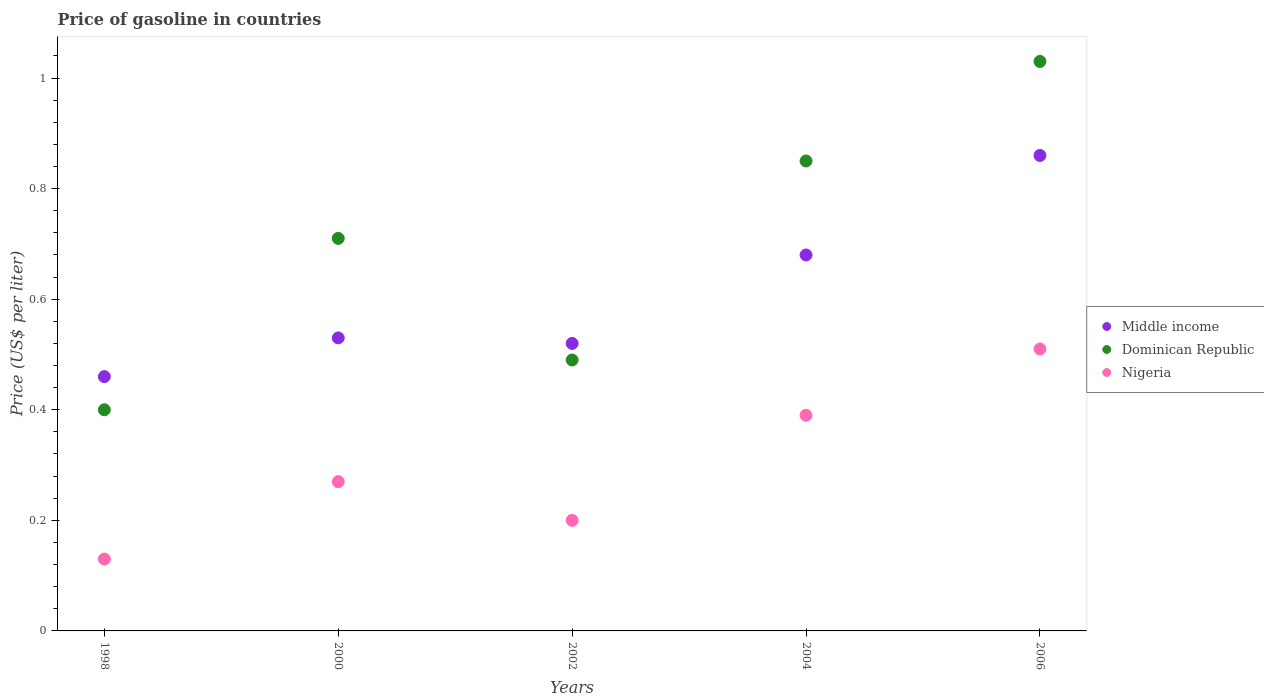Is the number of dotlines equal to the number of legend labels?
Your answer should be compact. Yes. What is the price of gasoline in Middle income in 2004?
Give a very brief answer. 0.68. Across all years, what is the maximum price of gasoline in Middle income?
Offer a very short reply. 0.86. Across all years, what is the minimum price of gasoline in Nigeria?
Provide a succinct answer. 0.13. What is the total price of gasoline in Dominican Republic in the graph?
Give a very brief answer. 3.48. What is the difference between the price of gasoline in Dominican Republic in 2004 and that in 2006?
Offer a very short reply. -0.18. What is the difference between the price of gasoline in Middle income in 2006 and the price of gasoline in Dominican Republic in 2000?
Offer a terse response. 0.15. What is the average price of gasoline in Nigeria per year?
Ensure brevity in your answer.  0.3. In the year 2006, what is the difference between the price of gasoline in Dominican Republic and price of gasoline in Middle income?
Give a very brief answer. 0.17. What is the ratio of the price of gasoline in Dominican Republic in 2002 to that in 2004?
Give a very brief answer. 0.58. Is the price of gasoline in Nigeria in 2000 less than that in 2006?
Offer a terse response. Yes. What is the difference between the highest and the second highest price of gasoline in Middle income?
Offer a very short reply. 0.18. What is the difference between the highest and the lowest price of gasoline in Dominican Republic?
Offer a terse response. 0.63. In how many years, is the price of gasoline in Nigeria greater than the average price of gasoline in Nigeria taken over all years?
Ensure brevity in your answer.  2. Is the sum of the price of gasoline in Dominican Republic in 2000 and 2002 greater than the maximum price of gasoline in Middle income across all years?
Ensure brevity in your answer.  Yes. Is the price of gasoline in Dominican Republic strictly greater than the price of gasoline in Nigeria over the years?
Give a very brief answer. Yes. What is the difference between two consecutive major ticks on the Y-axis?
Offer a very short reply. 0.2. Does the graph contain any zero values?
Provide a succinct answer. No. Does the graph contain grids?
Offer a terse response. No. Where does the legend appear in the graph?
Your answer should be compact. Center right. How many legend labels are there?
Provide a short and direct response. 3. What is the title of the graph?
Give a very brief answer. Price of gasoline in countries. What is the label or title of the X-axis?
Provide a succinct answer. Years. What is the label or title of the Y-axis?
Offer a terse response. Price (US$ per liter). What is the Price (US$ per liter) of Middle income in 1998?
Ensure brevity in your answer.  0.46. What is the Price (US$ per liter) in Nigeria in 1998?
Keep it short and to the point. 0.13. What is the Price (US$ per liter) in Middle income in 2000?
Your response must be concise. 0.53. What is the Price (US$ per liter) in Dominican Republic in 2000?
Provide a short and direct response. 0.71. What is the Price (US$ per liter) in Nigeria in 2000?
Your answer should be very brief. 0.27. What is the Price (US$ per liter) of Middle income in 2002?
Your answer should be very brief. 0.52. What is the Price (US$ per liter) of Dominican Republic in 2002?
Offer a very short reply. 0.49. What is the Price (US$ per liter) of Nigeria in 2002?
Offer a terse response. 0.2. What is the Price (US$ per liter) in Middle income in 2004?
Your answer should be very brief. 0.68. What is the Price (US$ per liter) in Nigeria in 2004?
Your answer should be compact. 0.39. What is the Price (US$ per liter) of Middle income in 2006?
Your answer should be very brief. 0.86. What is the Price (US$ per liter) in Dominican Republic in 2006?
Your answer should be very brief. 1.03. What is the Price (US$ per liter) in Nigeria in 2006?
Your response must be concise. 0.51. Across all years, what is the maximum Price (US$ per liter) of Middle income?
Offer a very short reply. 0.86. Across all years, what is the maximum Price (US$ per liter) in Dominican Republic?
Offer a terse response. 1.03. Across all years, what is the maximum Price (US$ per liter) in Nigeria?
Make the answer very short. 0.51. Across all years, what is the minimum Price (US$ per liter) of Middle income?
Your answer should be compact. 0.46. Across all years, what is the minimum Price (US$ per liter) in Dominican Republic?
Keep it short and to the point. 0.4. Across all years, what is the minimum Price (US$ per liter) in Nigeria?
Ensure brevity in your answer.  0.13. What is the total Price (US$ per liter) in Middle income in the graph?
Ensure brevity in your answer.  3.05. What is the total Price (US$ per liter) of Dominican Republic in the graph?
Your answer should be compact. 3.48. What is the difference between the Price (US$ per liter) of Middle income in 1998 and that in 2000?
Give a very brief answer. -0.07. What is the difference between the Price (US$ per liter) of Dominican Republic in 1998 and that in 2000?
Provide a short and direct response. -0.31. What is the difference between the Price (US$ per liter) of Nigeria in 1998 and that in 2000?
Give a very brief answer. -0.14. What is the difference between the Price (US$ per liter) in Middle income in 1998 and that in 2002?
Ensure brevity in your answer.  -0.06. What is the difference between the Price (US$ per liter) in Dominican Republic in 1998 and that in 2002?
Keep it short and to the point. -0.09. What is the difference between the Price (US$ per liter) of Nigeria in 1998 and that in 2002?
Ensure brevity in your answer.  -0.07. What is the difference between the Price (US$ per liter) of Middle income in 1998 and that in 2004?
Offer a terse response. -0.22. What is the difference between the Price (US$ per liter) of Dominican Republic in 1998 and that in 2004?
Provide a short and direct response. -0.45. What is the difference between the Price (US$ per liter) of Nigeria in 1998 and that in 2004?
Offer a very short reply. -0.26. What is the difference between the Price (US$ per liter) of Dominican Republic in 1998 and that in 2006?
Your answer should be very brief. -0.63. What is the difference between the Price (US$ per liter) in Nigeria in 1998 and that in 2006?
Your answer should be compact. -0.38. What is the difference between the Price (US$ per liter) in Dominican Republic in 2000 and that in 2002?
Provide a succinct answer. 0.22. What is the difference between the Price (US$ per liter) of Nigeria in 2000 and that in 2002?
Offer a very short reply. 0.07. What is the difference between the Price (US$ per liter) in Dominican Republic in 2000 and that in 2004?
Your answer should be compact. -0.14. What is the difference between the Price (US$ per liter) of Nigeria in 2000 and that in 2004?
Offer a terse response. -0.12. What is the difference between the Price (US$ per liter) of Middle income in 2000 and that in 2006?
Make the answer very short. -0.33. What is the difference between the Price (US$ per liter) of Dominican Republic in 2000 and that in 2006?
Offer a terse response. -0.32. What is the difference between the Price (US$ per liter) in Nigeria in 2000 and that in 2006?
Keep it short and to the point. -0.24. What is the difference between the Price (US$ per liter) in Middle income in 2002 and that in 2004?
Your response must be concise. -0.16. What is the difference between the Price (US$ per liter) of Dominican Republic in 2002 and that in 2004?
Keep it short and to the point. -0.36. What is the difference between the Price (US$ per liter) in Nigeria in 2002 and that in 2004?
Make the answer very short. -0.19. What is the difference between the Price (US$ per liter) in Middle income in 2002 and that in 2006?
Give a very brief answer. -0.34. What is the difference between the Price (US$ per liter) of Dominican Republic in 2002 and that in 2006?
Your answer should be compact. -0.54. What is the difference between the Price (US$ per liter) of Nigeria in 2002 and that in 2006?
Keep it short and to the point. -0.31. What is the difference between the Price (US$ per liter) in Middle income in 2004 and that in 2006?
Give a very brief answer. -0.18. What is the difference between the Price (US$ per liter) of Dominican Republic in 2004 and that in 2006?
Your response must be concise. -0.18. What is the difference between the Price (US$ per liter) in Nigeria in 2004 and that in 2006?
Your answer should be very brief. -0.12. What is the difference between the Price (US$ per liter) in Middle income in 1998 and the Price (US$ per liter) in Nigeria in 2000?
Your response must be concise. 0.19. What is the difference between the Price (US$ per liter) of Dominican Republic in 1998 and the Price (US$ per liter) of Nigeria in 2000?
Offer a very short reply. 0.13. What is the difference between the Price (US$ per liter) of Middle income in 1998 and the Price (US$ per liter) of Dominican Republic in 2002?
Your answer should be very brief. -0.03. What is the difference between the Price (US$ per liter) of Middle income in 1998 and the Price (US$ per liter) of Nigeria in 2002?
Ensure brevity in your answer.  0.26. What is the difference between the Price (US$ per liter) in Middle income in 1998 and the Price (US$ per liter) in Dominican Republic in 2004?
Your response must be concise. -0.39. What is the difference between the Price (US$ per liter) in Middle income in 1998 and the Price (US$ per liter) in Nigeria in 2004?
Provide a succinct answer. 0.07. What is the difference between the Price (US$ per liter) in Middle income in 1998 and the Price (US$ per liter) in Dominican Republic in 2006?
Offer a terse response. -0.57. What is the difference between the Price (US$ per liter) of Middle income in 1998 and the Price (US$ per liter) of Nigeria in 2006?
Offer a very short reply. -0.05. What is the difference between the Price (US$ per liter) of Dominican Republic in 1998 and the Price (US$ per liter) of Nigeria in 2006?
Give a very brief answer. -0.11. What is the difference between the Price (US$ per liter) of Middle income in 2000 and the Price (US$ per liter) of Nigeria in 2002?
Offer a terse response. 0.33. What is the difference between the Price (US$ per liter) in Dominican Republic in 2000 and the Price (US$ per liter) in Nigeria in 2002?
Offer a terse response. 0.51. What is the difference between the Price (US$ per liter) in Middle income in 2000 and the Price (US$ per liter) in Dominican Republic in 2004?
Provide a succinct answer. -0.32. What is the difference between the Price (US$ per liter) in Middle income in 2000 and the Price (US$ per liter) in Nigeria in 2004?
Make the answer very short. 0.14. What is the difference between the Price (US$ per liter) of Dominican Republic in 2000 and the Price (US$ per liter) of Nigeria in 2004?
Offer a very short reply. 0.32. What is the difference between the Price (US$ per liter) in Middle income in 2002 and the Price (US$ per liter) in Dominican Republic in 2004?
Provide a short and direct response. -0.33. What is the difference between the Price (US$ per liter) in Middle income in 2002 and the Price (US$ per liter) in Nigeria in 2004?
Give a very brief answer. 0.13. What is the difference between the Price (US$ per liter) in Dominican Republic in 2002 and the Price (US$ per liter) in Nigeria in 2004?
Your answer should be very brief. 0.1. What is the difference between the Price (US$ per liter) in Middle income in 2002 and the Price (US$ per liter) in Dominican Republic in 2006?
Ensure brevity in your answer.  -0.51. What is the difference between the Price (US$ per liter) of Dominican Republic in 2002 and the Price (US$ per liter) of Nigeria in 2006?
Provide a short and direct response. -0.02. What is the difference between the Price (US$ per liter) of Middle income in 2004 and the Price (US$ per liter) of Dominican Republic in 2006?
Make the answer very short. -0.35. What is the difference between the Price (US$ per liter) in Middle income in 2004 and the Price (US$ per liter) in Nigeria in 2006?
Ensure brevity in your answer.  0.17. What is the difference between the Price (US$ per liter) in Dominican Republic in 2004 and the Price (US$ per liter) in Nigeria in 2006?
Make the answer very short. 0.34. What is the average Price (US$ per liter) of Middle income per year?
Give a very brief answer. 0.61. What is the average Price (US$ per liter) in Dominican Republic per year?
Your response must be concise. 0.7. What is the average Price (US$ per liter) in Nigeria per year?
Ensure brevity in your answer.  0.3. In the year 1998, what is the difference between the Price (US$ per liter) of Middle income and Price (US$ per liter) of Nigeria?
Ensure brevity in your answer.  0.33. In the year 1998, what is the difference between the Price (US$ per liter) in Dominican Republic and Price (US$ per liter) in Nigeria?
Your response must be concise. 0.27. In the year 2000, what is the difference between the Price (US$ per liter) in Middle income and Price (US$ per liter) in Dominican Republic?
Offer a very short reply. -0.18. In the year 2000, what is the difference between the Price (US$ per liter) of Middle income and Price (US$ per liter) of Nigeria?
Offer a terse response. 0.26. In the year 2000, what is the difference between the Price (US$ per liter) in Dominican Republic and Price (US$ per liter) in Nigeria?
Make the answer very short. 0.44. In the year 2002, what is the difference between the Price (US$ per liter) in Middle income and Price (US$ per liter) in Nigeria?
Provide a succinct answer. 0.32. In the year 2002, what is the difference between the Price (US$ per liter) in Dominican Republic and Price (US$ per liter) in Nigeria?
Ensure brevity in your answer.  0.29. In the year 2004, what is the difference between the Price (US$ per liter) in Middle income and Price (US$ per liter) in Dominican Republic?
Offer a terse response. -0.17. In the year 2004, what is the difference between the Price (US$ per liter) of Middle income and Price (US$ per liter) of Nigeria?
Your response must be concise. 0.29. In the year 2004, what is the difference between the Price (US$ per liter) in Dominican Republic and Price (US$ per liter) in Nigeria?
Make the answer very short. 0.46. In the year 2006, what is the difference between the Price (US$ per liter) of Middle income and Price (US$ per liter) of Dominican Republic?
Keep it short and to the point. -0.17. In the year 2006, what is the difference between the Price (US$ per liter) of Middle income and Price (US$ per liter) of Nigeria?
Provide a succinct answer. 0.35. In the year 2006, what is the difference between the Price (US$ per liter) in Dominican Republic and Price (US$ per liter) in Nigeria?
Offer a very short reply. 0.52. What is the ratio of the Price (US$ per liter) of Middle income in 1998 to that in 2000?
Your response must be concise. 0.87. What is the ratio of the Price (US$ per liter) of Dominican Republic in 1998 to that in 2000?
Your answer should be very brief. 0.56. What is the ratio of the Price (US$ per liter) of Nigeria in 1998 to that in 2000?
Provide a succinct answer. 0.48. What is the ratio of the Price (US$ per liter) of Middle income in 1998 to that in 2002?
Your answer should be very brief. 0.88. What is the ratio of the Price (US$ per liter) in Dominican Republic in 1998 to that in 2002?
Keep it short and to the point. 0.82. What is the ratio of the Price (US$ per liter) in Nigeria in 1998 to that in 2002?
Ensure brevity in your answer.  0.65. What is the ratio of the Price (US$ per liter) in Middle income in 1998 to that in 2004?
Your response must be concise. 0.68. What is the ratio of the Price (US$ per liter) of Dominican Republic in 1998 to that in 2004?
Provide a succinct answer. 0.47. What is the ratio of the Price (US$ per liter) in Middle income in 1998 to that in 2006?
Offer a terse response. 0.53. What is the ratio of the Price (US$ per liter) of Dominican Republic in 1998 to that in 2006?
Your answer should be compact. 0.39. What is the ratio of the Price (US$ per liter) in Nigeria in 1998 to that in 2006?
Provide a succinct answer. 0.25. What is the ratio of the Price (US$ per liter) in Middle income in 2000 to that in 2002?
Your answer should be very brief. 1.02. What is the ratio of the Price (US$ per liter) of Dominican Republic in 2000 to that in 2002?
Your answer should be very brief. 1.45. What is the ratio of the Price (US$ per liter) in Nigeria in 2000 to that in 2002?
Your answer should be compact. 1.35. What is the ratio of the Price (US$ per liter) in Middle income in 2000 to that in 2004?
Ensure brevity in your answer.  0.78. What is the ratio of the Price (US$ per liter) in Dominican Republic in 2000 to that in 2004?
Your answer should be very brief. 0.84. What is the ratio of the Price (US$ per liter) of Nigeria in 2000 to that in 2004?
Make the answer very short. 0.69. What is the ratio of the Price (US$ per liter) of Middle income in 2000 to that in 2006?
Give a very brief answer. 0.62. What is the ratio of the Price (US$ per liter) in Dominican Republic in 2000 to that in 2006?
Provide a short and direct response. 0.69. What is the ratio of the Price (US$ per liter) of Nigeria in 2000 to that in 2006?
Provide a succinct answer. 0.53. What is the ratio of the Price (US$ per liter) of Middle income in 2002 to that in 2004?
Give a very brief answer. 0.76. What is the ratio of the Price (US$ per liter) in Dominican Republic in 2002 to that in 2004?
Give a very brief answer. 0.58. What is the ratio of the Price (US$ per liter) of Nigeria in 2002 to that in 2004?
Make the answer very short. 0.51. What is the ratio of the Price (US$ per liter) of Middle income in 2002 to that in 2006?
Offer a terse response. 0.6. What is the ratio of the Price (US$ per liter) of Dominican Republic in 2002 to that in 2006?
Your response must be concise. 0.48. What is the ratio of the Price (US$ per liter) in Nigeria in 2002 to that in 2006?
Keep it short and to the point. 0.39. What is the ratio of the Price (US$ per liter) of Middle income in 2004 to that in 2006?
Offer a terse response. 0.79. What is the ratio of the Price (US$ per liter) in Dominican Republic in 2004 to that in 2006?
Offer a very short reply. 0.83. What is the ratio of the Price (US$ per liter) of Nigeria in 2004 to that in 2006?
Your answer should be compact. 0.76. What is the difference between the highest and the second highest Price (US$ per liter) of Middle income?
Your answer should be compact. 0.18. What is the difference between the highest and the second highest Price (US$ per liter) in Dominican Republic?
Give a very brief answer. 0.18. What is the difference between the highest and the second highest Price (US$ per liter) in Nigeria?
Your answer should be very brief. 0.12. What is the difference between the highest and the lowest Price (US$ per liter) in Middle income?
Your response must be concise. 0.4. What is the difference between the highest and the lowest Price (US$ per liter) of Dominican Republic?
Keep it short and to the point. 0.63. What is the difference between the highest and the lowest Price (US$ per liter) in Nigeria?
Keep it short and to the point. 0.38. 